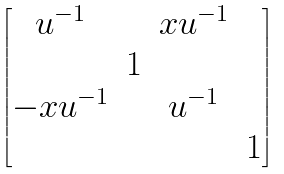<formula> <loc_0><loc_0><loc_500><loc_500>\begin{bmatrix} u ^ { - 1 } & & x u ^ { - 1 } \\ & 1 \\ - x u ^ { - 1 } & & u ^ { - 1 } \\ & & & 1 \end{bmatrix}</formula> 